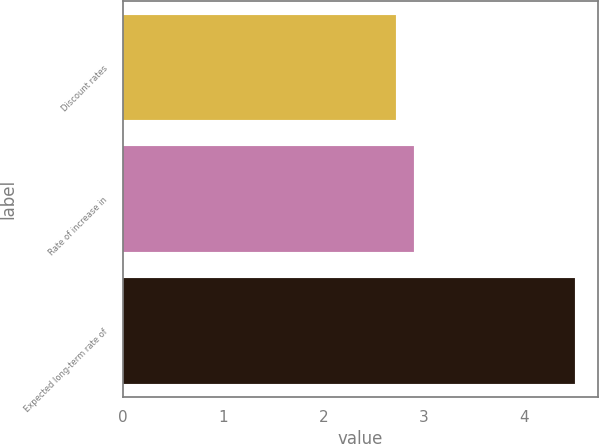<chart> <loc_0><loc_0><loc_500><loc_500><bar_chart><fcel>Discount rates<fcel>Rate of increase in<fcel>Expected long-term rate of<nl><fcel>2.72<fcel>2.9<fcel>4.51<nl></chart> 